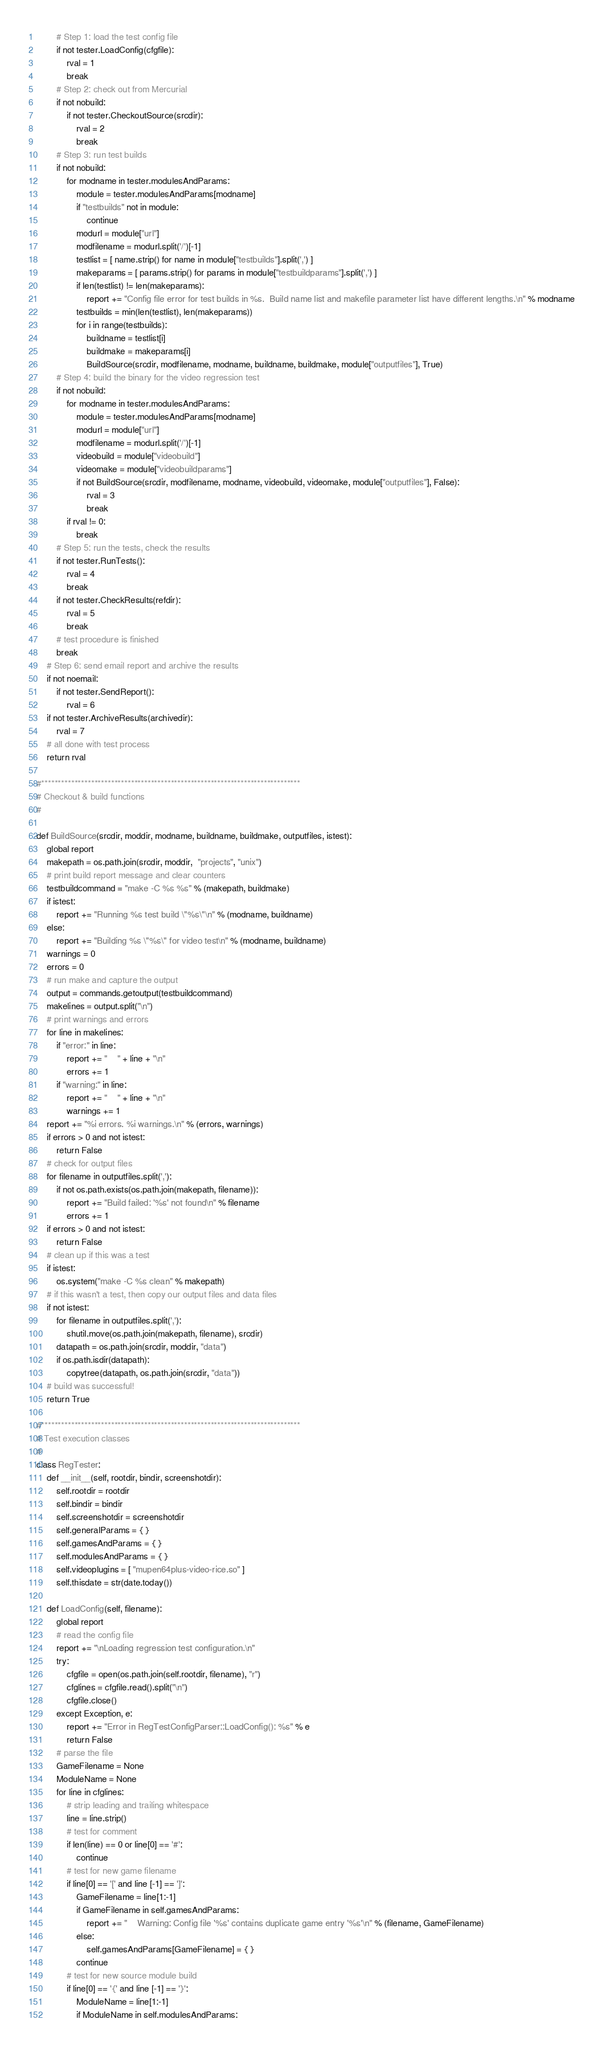<code> <loc_0><loc_0><loc_500><loc_500><_Python_>        # Step 1: load the test config file
        if not tester.LoadConfig(cfgfile):
            rval = 1
            break
        # Step 2: check out from Mercurial
        if not nobuild:
            if not tester.CheckoutSource(srcdir):
                rval = 2
                break
        # Step 3: run test builds
        if not nobuild:
            for modname in tester.modulesAndParams:
                module = tester.modulesAndParams[modname]
                if "testbuilds" not in module:
                    continue
                modurl = module["url"]
                modfilename = modurl.split('/')[-1]
                testlist = [ name.strip() for name in module["testbuilds"].split(',') ]
                makeparams = [ params.strip() for params in module["testbuildparams"].split(',') ]
                if len(testlist) != len(makeparams):
                    report += "Config file error for test builds in %s.  Build name list and makefile parameter list have different lengths.\n" % modname
                testbuilds = min(len(testlist), len(makeparams))
                for i in range(testbuilds):
                    buildname = testlist[i]
                    buildmake = makeparams[i]
                    BuildSource(srcdir, modfilename, modname, buildname, buildmake, module["outputfiles"], True)
        # Step 4: build the binary for the video regression test
        if not nobuild:
            for modname in tester.modulesAndParams:
                module = tester.modulesAndParams[modname]
                modurl = module["url"]
                modfilename = modurl.split('/')[-1]
                videobuild = module["videobuild"]
                videomake = module["videobuildparams"]
                if not BuildSource(srcdir, modfilename, modname, videobuild, videomake, module["outputfiles"], False):
                    rval = 3
                    break
            if rval != 0:
                break
        # Step 5: run the tests, check the results
        if not tester.RunTests():
            rval = 4
            break
        if not tester.CheckResults(refdir):
            rval = 5
            break
        # test procedure is finished
        break
    # Step 6: send email report and archive the results
    if not noemail:
    	if not tester.SendReport():
        	rval = 6
    if not tester.ArchiveResults(archivedir):
        rval = 7
    # all done with test process
    return rval

#******************************************************************************
# Checkout & build functions
#

def BuildSource(srcdir, moddir, modname, buildname, buildmake, outputfiles, istest):
    global report
    makepath = os.path.join(srcdir, moddir,  "projects", "unix")
    # print build report message and clear counters
    testbuildcommand = "make -C %s %s" % (makepath, buildmake)
    if istest:
        report += "Running %s test build \"%s\"\n" % (modname, buildname)
    else:
        report += "Building %s \"%s\" for video test\n" % (modname, buildname)
    warnings = 0
    errors = 0
    # run make and capture the output
    output = commands.getoutput(testbuildcommand)
    makelines = output.split("\n")
    # print warnings and errors
    for line in makelines:
        if "error:" in line:
            report += "    " + line + "\n"
            errors += 1
        if "warning:" in line:
            report += "    " + line + "\n"
            warnings += 1
    report += "%i errors. %i warnings.\n" % (errors, warnings)
    if errors > 0 and not istest:
        return False
    # check for output files
    for filename in outputfiles.split(','):
        if not os.path.exists(os.path.join(makepath, filename)):
            report += "Build failed: '%s' not found\n" % filename
            errors += 1
    if errors > 0 and not istest:
        return False
    # clean up if this was a test
    if istest:
        os.system("make -C %s clean" % makepath)
    # if this wasn't a test, then copy our output files and data files
    if not istest:
        for filename in outputfiles.split(','):
            shutil.move(os.path.join(makepath, filename), srcdir)
        datapath = os.path.join(srcdir, moddir, "data")
        if os.path.isdir(datapath):
            copytree(datapath, os.path.join(srcdir, "data"))
    # build was successful!
    return True

#******************************************************************************
# Test execution classes
#
class RegTester:
    def __init__(self, rootdir, bindir, screenshotdir):
        self.rootdir = rootdir
        self.bindir = bindir
        self.screenshotdir = screenshotdir
        self.generalParams = { }
        self.gamesAndParams = { }
        self.modulesAndParams = { }
        self.videoplugins = [ "mupen64plus-video-rice.so" ]
        self.thisdate = str(date.today())

    def LoadConfig(self, filename):
        global report
        # read the config file
        report += "\nLoading regression test configuration.\n"
        try:
            cfgfile = open(os.path.join(self.rootdir, filename), "r")
            cfglines = cfgfile.read().split("\n")
            cfgfile.close()
        except Exception, e:
            report += "Error in RegTestConfigParser::LoadConfig(): %s" % e
            return False
        # parse the file
        GameFilename = None
        ModuleName = None
        for line in cfglines:
            # strip leading and trailing whitespace
            line = line.strip()
            # test for comment
            if len(line) == 0 or line[0] == '#':
                continue
            # test for new game filename
            if line[0] == '[' and line [-1] == ']':
                GameFilename = line[1:-1]
                if GameFilename in self.gamesAndParams:
                    report += "    Warning: Config file '%s' contains duplicate game entry '%s'\n" % (filename, GameFilename)
                else:
                    self.gamesAndParams[GameFilename] = { }
                continue
            # test for new source module build
            if line[0] == '{' and line [-1] == '}':
                ModuleName = line[1:-1]
                if ModuleName in self.modulesAndParams:</code> 